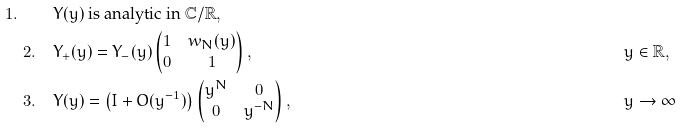Convert formula to latex. <formula><loc_0><loc_0><loc_500><loc_500>1 . \quad & \text {$Y(y)$ is analytic in $\mathbb{C}/\mathbb{R}$} , & & \\ 2 . \quad & Y _ { + } ( y ) = Y _ { - } ( y ) \begin{pmatrix} 1 & w _ { N } ( y ) \\ 0 & 1 \end{pmatrix} , & & y \in \mathbb { R } , \\ 3 . \quad & Y ( y ) = \left ( I + O ( y ^ { - 1 } ) \right ) \begin{pmatrix} y ^ { N } & 0 \\ 0 & y ^ { - N } \end{pmatrix} , & \quad & y \rightarrow \infty</formula> 